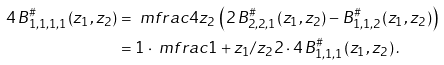Convert formula to latex. <formula><loc_0><loc_0><loc_500><loc_500>4 \, B ^ { \# } _ { 1 , 1 , 1 , 1 } ( z _ { 1 } , z _ { 2 } ) & = \ m f r a c { 4 } { z _ { 2 } } \, \left ( 2 \, B ^ { \# } _ { 2 , 2 , 1 } ( z _ { 1 } , z _ { 2 } ) - B ^ { \# } _ { 1 , 1 , 2 } ( z _ { 1 } , z _ { 2 } ) \right ) \\ & = 1 \cdot \ m f r a c { 1 + z _ { 1 } / z _ { 2 } } { 2 } \cdot 4 \, B ^ { \# } _ { 1 , 1 , 1 } ( z _ { 1 } , z _ { 2 } ) \, .</formula> 